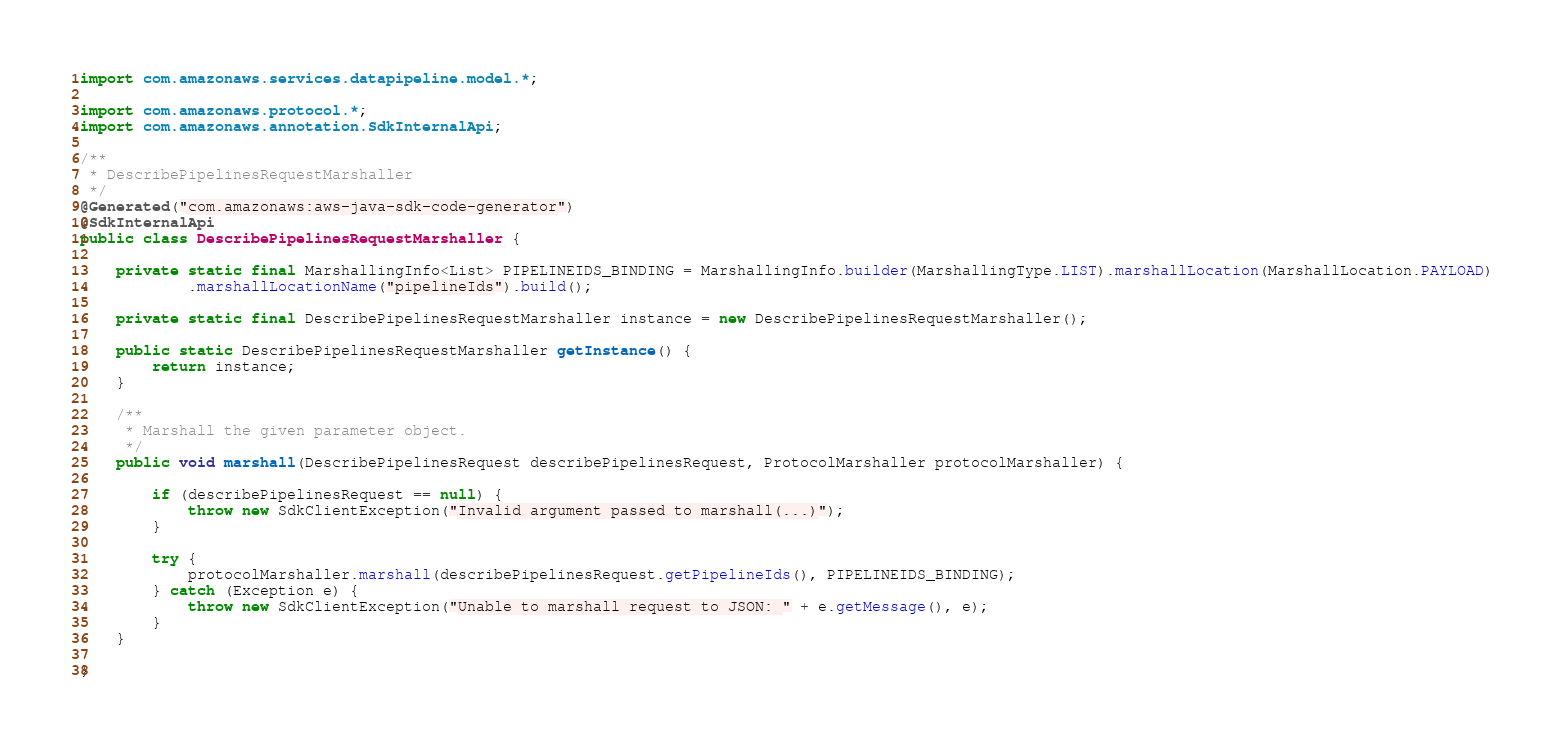<code> <loc_0><loc_0><loc_500><loc_500><_Java_>import com.amazonaws.services.datapipeline.model.*;

import com.amazonaws.protocol.*;
import com.amazonaws.annotation.SdkInternalApi;

/**
 * DescribePipelinesRequestMarshaller
 */
@Generated("com.amazonaws:aws-java-sdk-code-generator")
@SdkInternalApi
public class DescribePipelinesRequestMarshaller {

    private static final MarshallingInfo<List> PIPELINEIDS_BINDING = MarshallingInfo.builder(MarshallingType.LIST).marshallLocation(MarshallLocation.PAYLOAD)
            .marshallLocationName("pipelineIds").build();

    private static final DescribePipelinesRequestMarshaller instance = new DescribePipelinesRequestMarshaller();

    public static DescribePipelinesRequestMarshaller getInstance() {
        return instance;
    }

    /**
     * Marshall the given parameter object.
     */
    public void marshall(DescribePipelinesRequest describePipelinesRequest, ProtocolMarshaller protocolMarshaller) {

        if (describePipelinesRequest == null) {
            throw new SdkClientException("Invalid argument passed to marshall(...)");
        }

        try {
            protocolMarshaller.marshall(describePipelinesRequest.getPipelineIds(), PIPELINEIDS_BINDING);
        } catch (Exception e) {
            throw new SdkClientException("Unable to marshall request to JSON: " + e.getMessage(), e);
        }
    }

}
</code> 